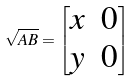Convert formula to latex. <formula><loc_0><loc_0><loc_500><loc_500>\sqrt { A B } = \begin{bmatrix} x & 0 \\ y & 0 \end{bmatrix}</formula> 